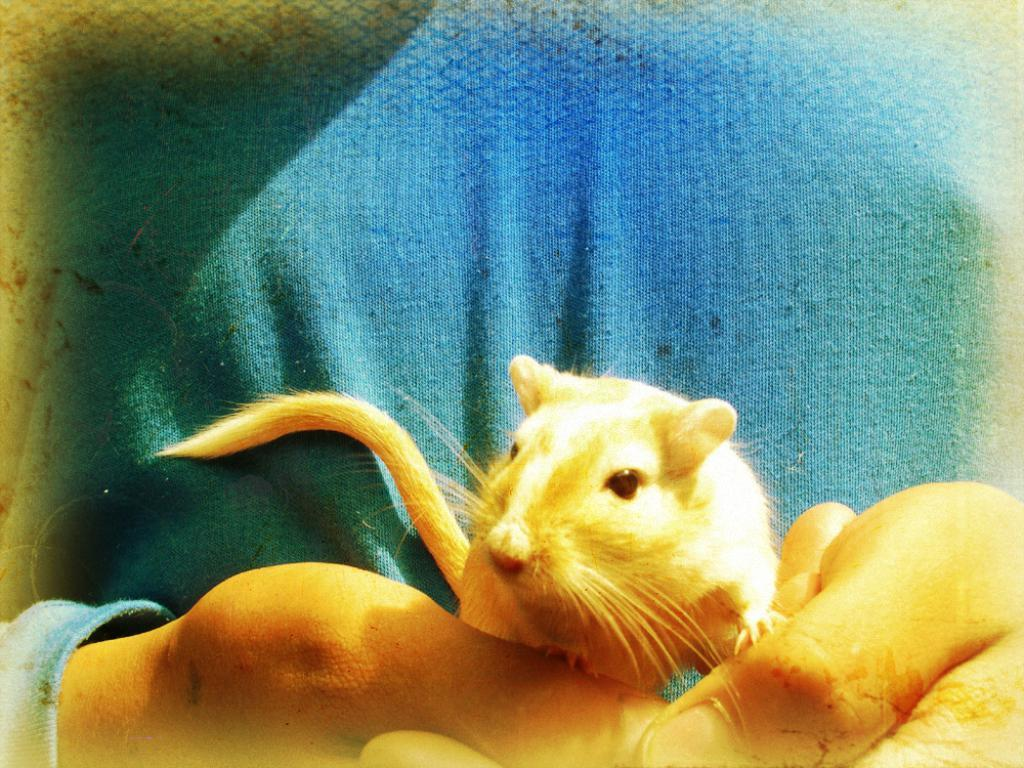Who or what is present in the image? There is a person in the image. What is the person holding in the image? The person is holding a mouse. What time of day is it in the image, given the presence of a news broadcast? There is no news broadcast or indication of time of day in the image; it only shows a person holding a mouse. 